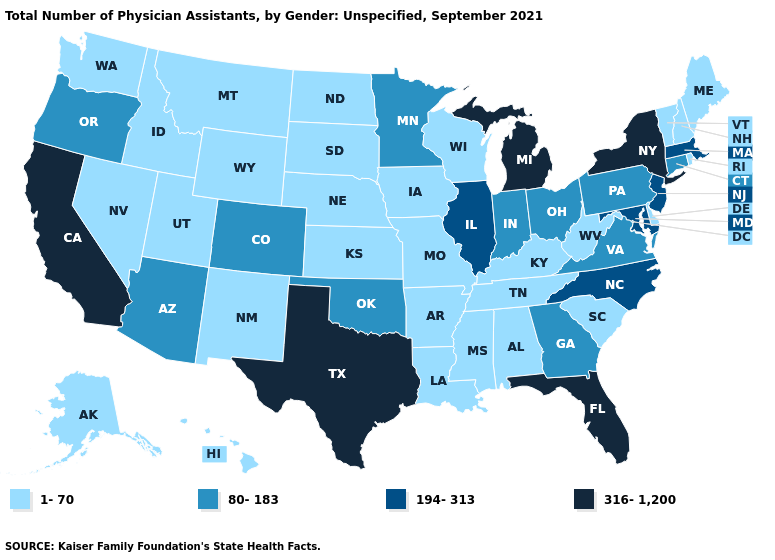What is the value of Alaska?
Answer briefly. 1-70. What is the value of Oregon?
Quick response, please. 80-183. What is the value of Colorado?
Write a very short answer. 80-183. Does Arkansas have the lowest value in the USA?
Quick response, please. Yes. What is the lowest value in states that border South Carolina?
Keep it brief. 80-183. What is the value of Alabama?
Quick response, please. 1-70. What is the value of North Dakota?
Concise answer only. 1-70. How many symbols are there in the legend?
Give a very brief answer. 4. Does Delaware have a higher value than Utah?
Give a very brief answer. No. What is the value of Iowa?
Write a very short answer. 1-70. What is the lowest value in the Northeast?
Keep it brief. 1-70. What is the highest value in states that border Virginia?
Quick response, please. 194-313. What is the value of Kansas?
Short answer required. 1-70. What is the lowest value in states that border Texas?
Short answer required. 1-70. Does the map have missing data?
Write a very short answer. No. 